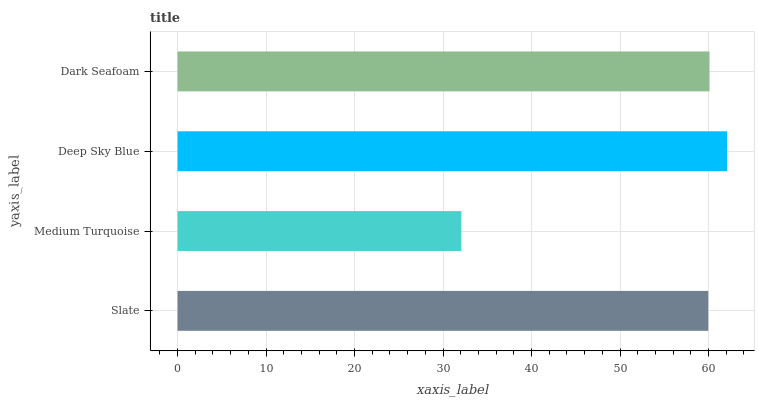Is Medium Turquoise the minimum?
Answer yes or no. Yes. Is Deep Sky Blue the maximum?
Answer yes or no. Yes. Is Deep Sky Blue the minimum?
Answer yes or no. No. Is Medium Turquoise the maximum?
Answer yes or no. No. Is Deep Sky Blue greater than Medium Turquoise?
Answer yes or no. Yes. Is Medium Turquoise less than Deep Sky Blue?
Answer yes or no. Yes. Is Medium Turquoise greater than Deep Sky Blue?
Answer yes or no. No. Is Deep Sky Blue less than Medium Turquoise?
Answer yes or no. No. Is Dark Seafoam the high median?
Answer yes or no. Yes. Is Slate the low median?
Answer yes or no. Yes. Is Medium Turquoise the high median?
Answer yes or no. No. Is Deep Sky Blue the low median?
Answer yes or no. No. 